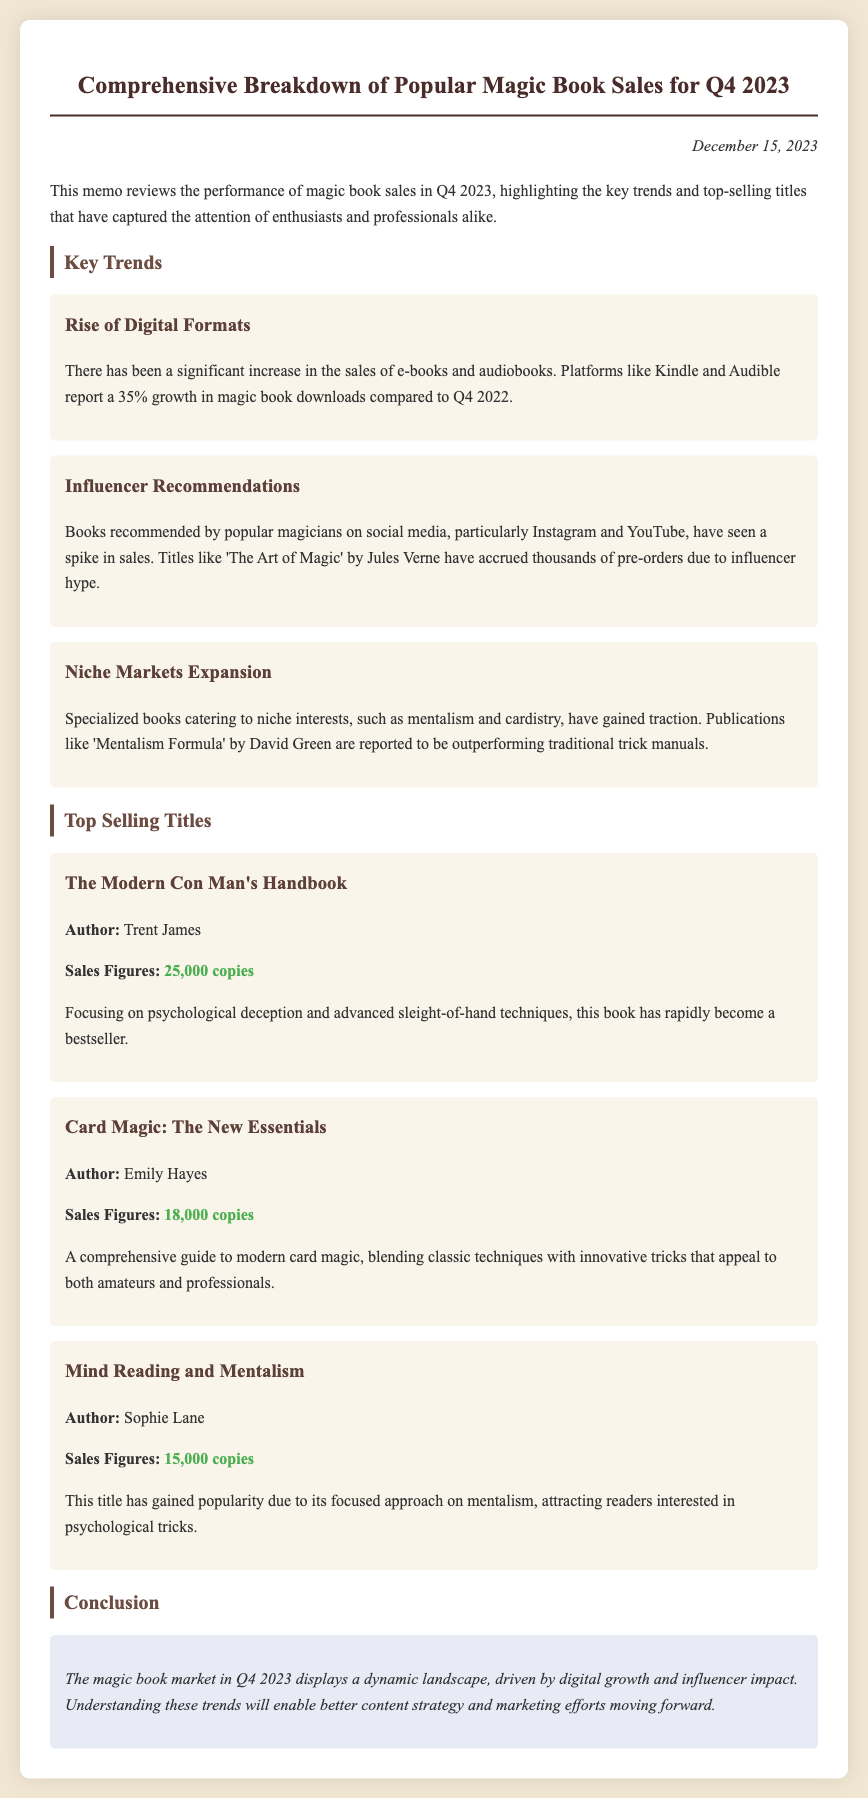What was the date of the memo? The date of the memo is mentioned at the top of the document as December 15, 2023.
Answer: December 15, 2023 What is the sales figure for 'The Modern Con Man's Handbook'? The sales figures provided in the document state it sold 25,000 copies.
Answer: 25,000 copies Which author wrote 'Mind Reading and Mentalism'? The document states that Sophie Lane is the author of this title.
Answer: Sophie Lane What is the percentage growth in magic book downloads for digital formats? The document highlights a 35% growth in downloads compared to the same period last year.
Answer: 35% Which trend relates to social media recommendations? The trend specifically discusses how influencer recommendations have impacted book sales.
Answer: Influencer Recommendations What niche interest trend is noted in the memo? The memo mentions the expansion of specialized books catering to niche interests like mentalism and cardistry.
Answer: Niche Markets Expansion Which book ranked second in sales figures? The document lists 'Card Magic: The New Essentials' as the second highest-selling title.
Answer: Card Magic: The New Essentials What key conclusion is drawn regarding the magic book market? The conclusion emphasizes that the market shows a dynamic landscape driven by digital growth and influencer impact.
Answer: Dynamic landscape What type of publication showed a spike due to influencer hype? The memo indicates that books recommended by popular magicians on social media saw an increase in sales.
Answer: Books recommended by popular magicians 